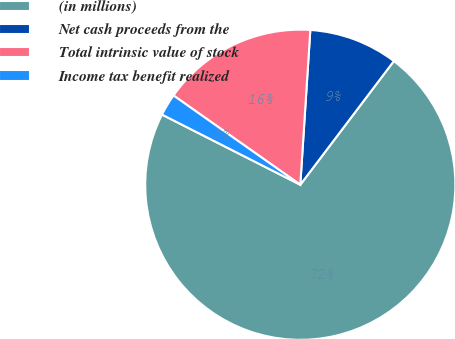<chart> <loc_0><loc_0><loc_500><loc_500><pie_chart><fcel>(in millions)<fcel>Net cash proceeds from the<fcel>Total intrinsic value of stock<fcel>Income tax benefit realized<nl><fcel>72.17%<fcel>9.28%<fcel>16.27%<fcel>2.29%<nl></chart> 